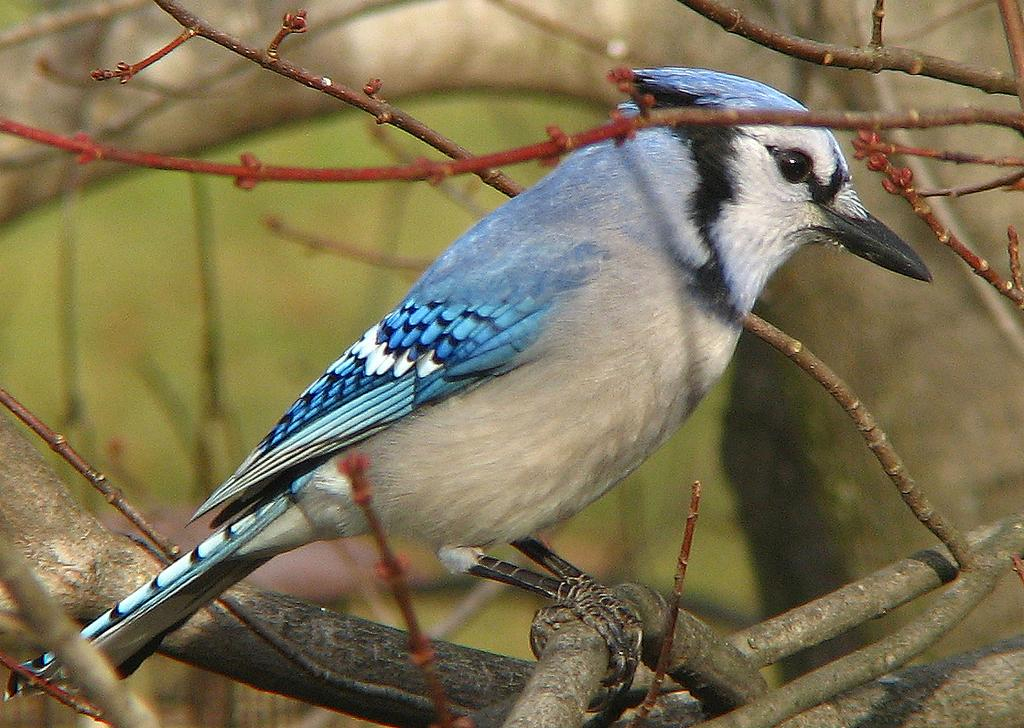What type of animal can be seen in the image? There is a bird in the image. Where is the bird located in the image? The bird is on the branches of a tree. What type of cushion is the bird sitting on in the image? There is no cushion present in the image; the bird is sitting on the branches of a tree. 